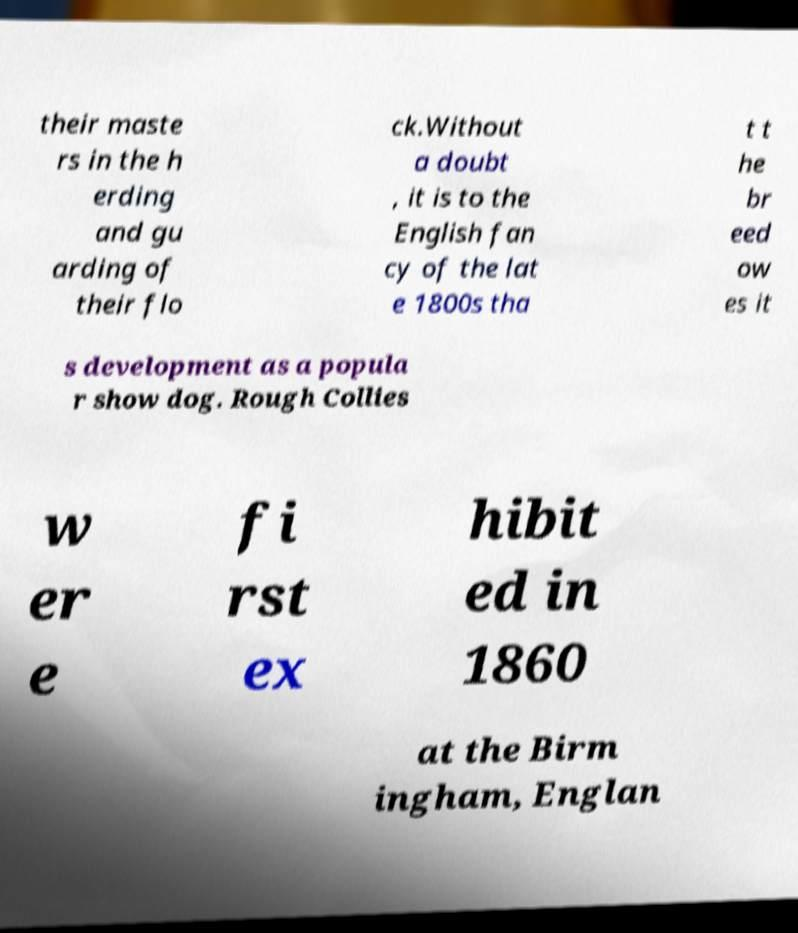There's text embedded in this image that I need extracted. Can you transcribe it verbatim? their maste rs in the h erding and gu arding of their flo ck.Without a doubt , it is to the English fan cy of the lat e 1800s tha t t he br eed ow es it s development as a popula r show dog. Rough Collies w er e fi rst ex hibit ed in 1860 at the Birm ingham, Englan 